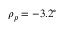<formula> <loc_0><loc_0><loc_500><loc_500>\rho _ { p } = - 3 . 2 ^ { \circ }</formula> 